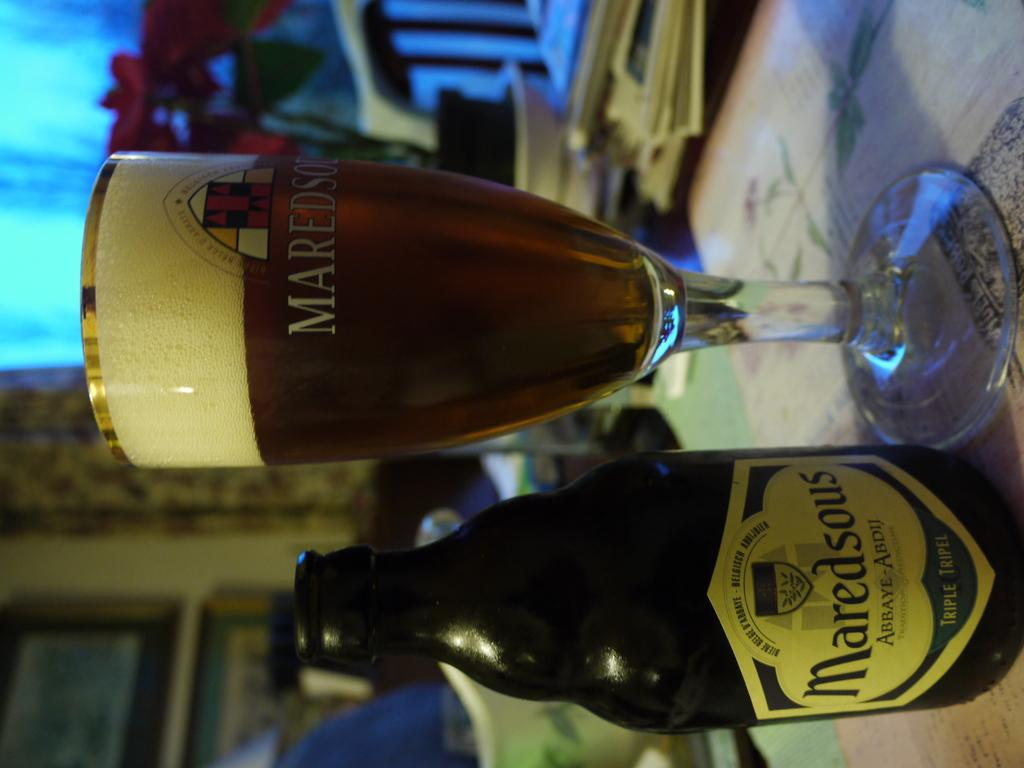<image>
Describe the image concisely. A refreshing Maredsous beverage awaits you on the table. 